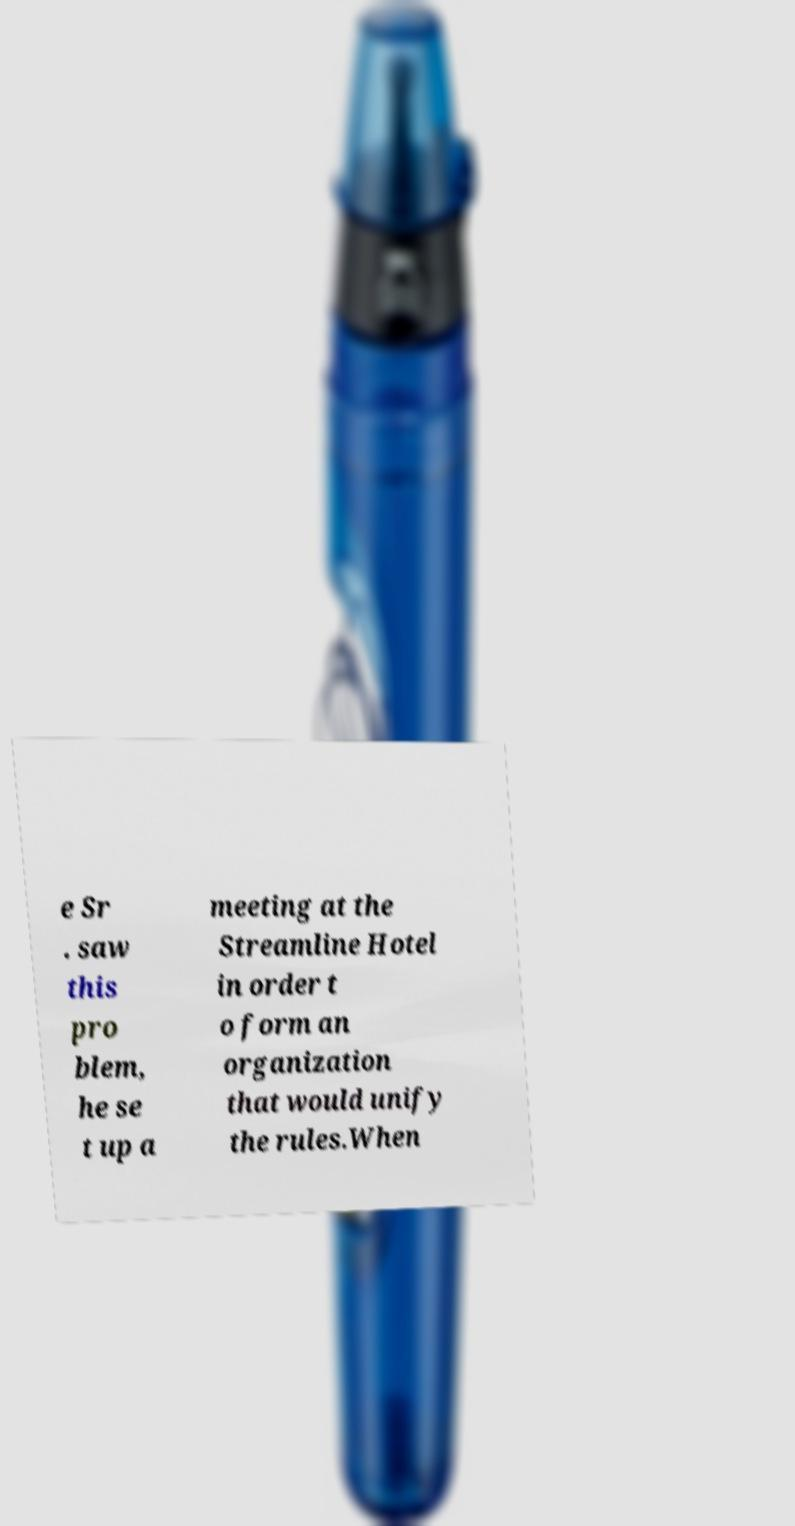I need the written content from this picture converted into text. Can you do that? e Sr . saw this pro blem, he se t up a meeting at the Streamline Hotel in order t o form an organization that would unify the rules.When 